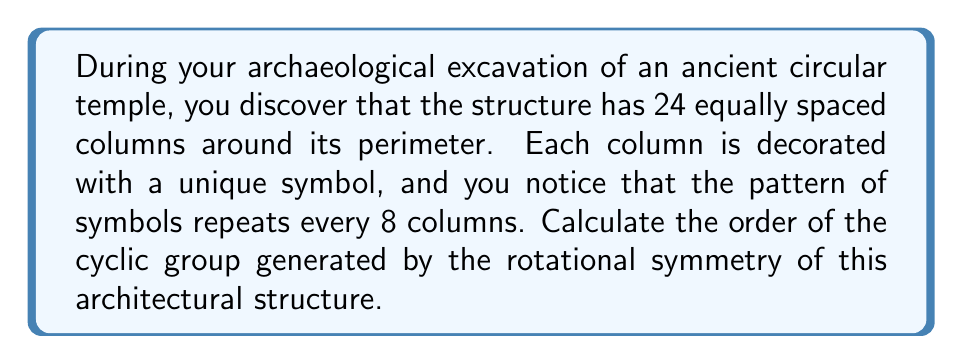Teach me how to tackle this problem. To solve this problem, we need to understand the concept of cyclic groups in the context of rotational symmetry:

1. The rotational symmetry of the temple forms a cyclic group, where each rotation is an element of the group.

2. The order of a cyclic group is the number of unique elements in the group before it returns to the identity element (a full 360° rotation in this case).

3. We can determine this by finding the smallest rotation that generates all possible symmetries:

   - Total number of columns: 24
   - Pattern repeats every: 8 columns

4. The smallest rotation that generates the group is a rotation by $\frac{360°}{24} = 15°$ (one column).

5. To find how many rotations it takes to return to the starting position:

   $$\text{Number of rotations} = \frac{\text{Total columns}}{\text{Pattern repeat}} = \frac{24}{8} = 3$$

6. This means that after 3 rotations of 15°, or 45°, we return to a configuration that looks identical to the starting position.

7. Therefore, the distinct elements of the cyclic group are:
   - Identity (0° rotation)
   - 15° rotation
   - 30° rotation

8. The order of the cyclic group is the number of these distinct elements, which is 3.
Answer: The order of the cyclic group generated by the rotational symmetry of the ancient temple is 3. 